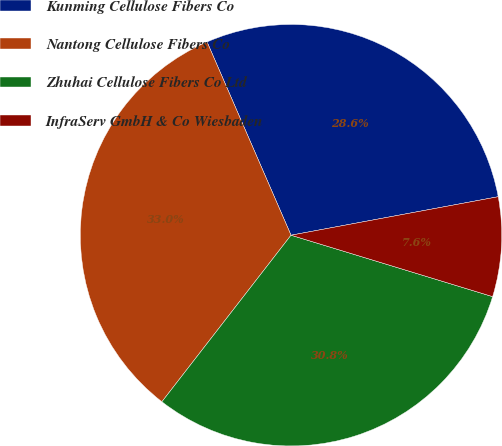Convert chart. <chart><loc_0><loc_0><loc_500><loc_500><pie_chart><fcel>Kunming Cellulose Fibers Co<fcel>Nantong Cellulose Fibers Co<fcel>Zhuhai Cellulose Fibers Co Ltd<fcel>InfraServ GmbH & Co Wiesbaden<nl><fcel>28.6%<fcel>32.98%<fcel>30.79%<fcel>7.63%<nl></chart> 